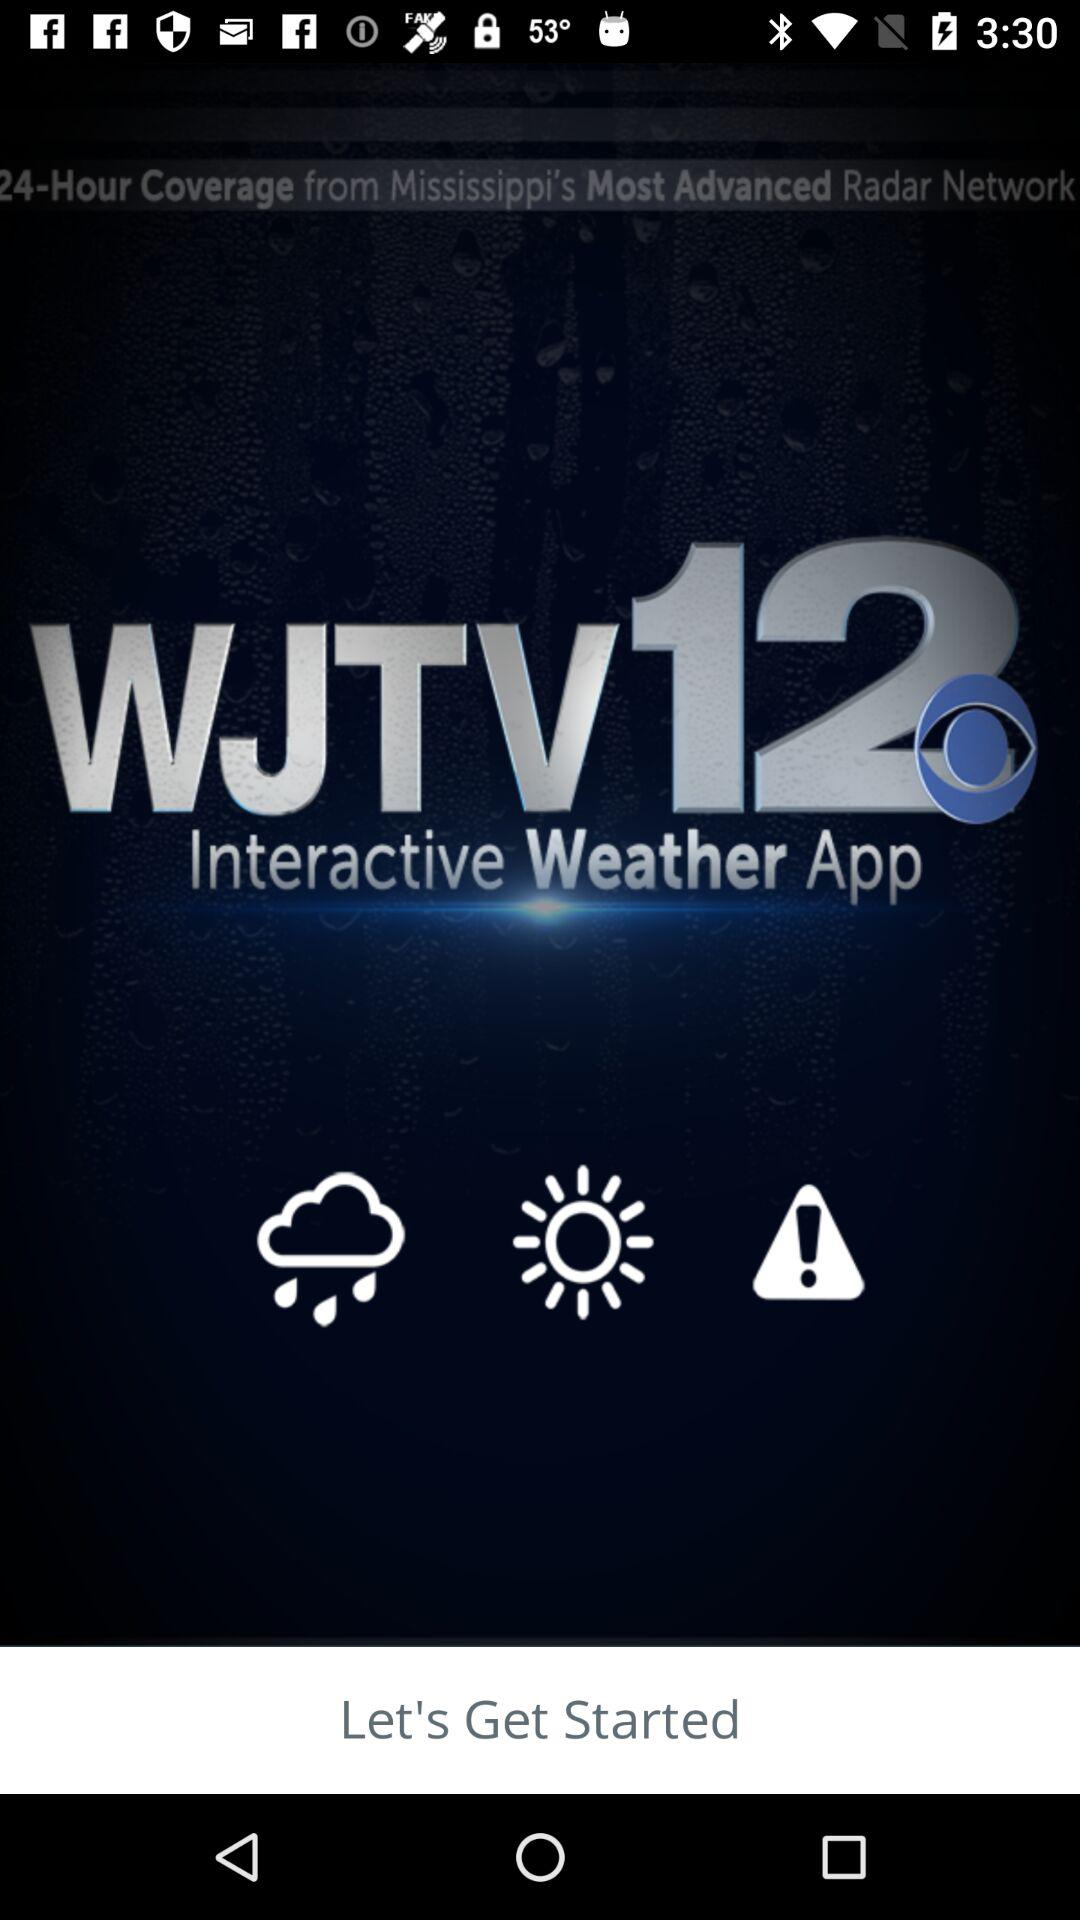What is the application name? The application name is "WJTV12". 